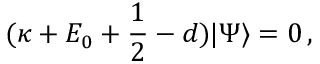<formula> <loc_0><loc_0><loc_500><loc_500>( \kappa + E _ { 0 } + \frac { 1 } { 2 } - d ) | \Psi \rangle = 0 \, ,</formula> 